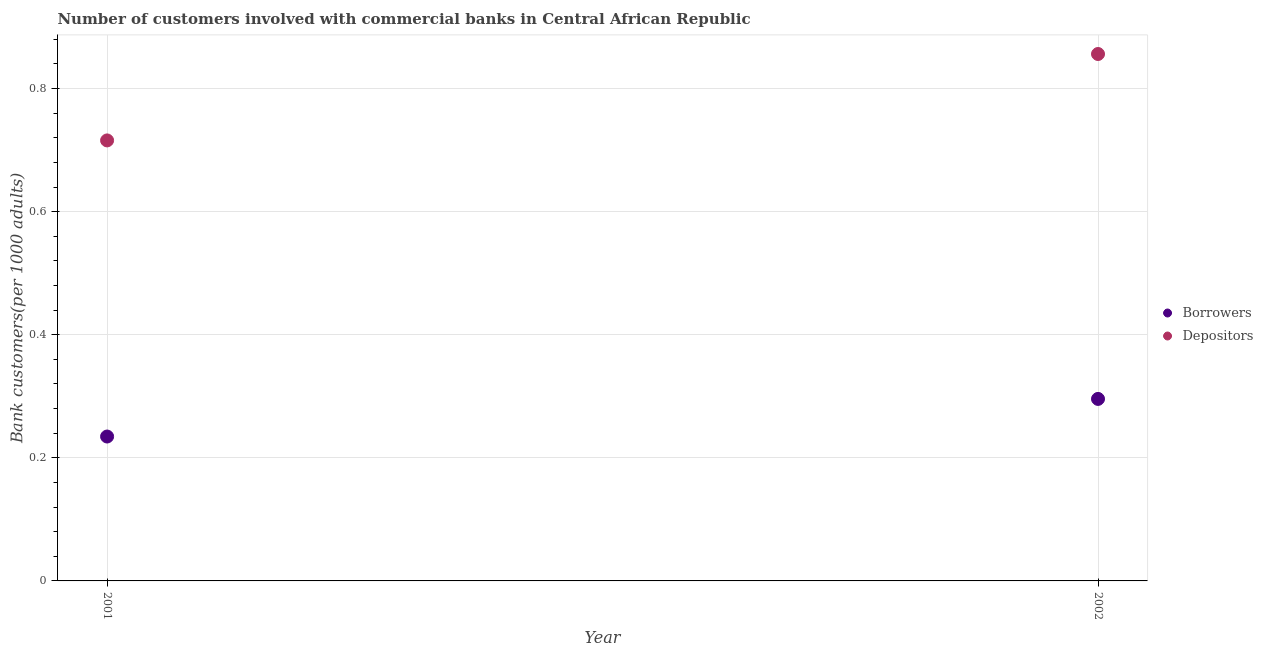Is the number of dotlines equal to the number of legend labels?
Ensure brevity in your answer.  Yes. What is the number of depositors in 2002?
Give a very brief answer. 0.86. Across all years, what is the maximum number of depositors?
Your response must be concise. 0.86. Across all years, what is the minimum number of depositors?
Your answer should be compact. 0.72. In which year was the number of borrowers maximum?
Your answer should be compact. 2002. In which year was the number of depositors minimum?
Your answer should be compact. 2001. What is the total number of borrowers in the graph?
Your response must be concise. 0.53. What is the difference between the number of borrowers in 2001 and that in 2002?
Your answer should be very brief. -0.06. What is the difference between the number of depositors in 2001 and the number of borrowers in 2002?
Provide a succinct answer. 0.42. What is the average number of borrowers per year?
Provide a succinct answer. 0.27. In the year 2001, what is the difference between the number of borrowers and number of depositors?
Make the answer very short. -0.48. What is the ratio of the number of borrowers in 2001 to that in 2002?
Give a very brief answer. 0.79. Is the number of depositors in 2001 less than that in 2002?
Keep it short and to the point. Yes. In how many years, is the number of depositors greater than the average number of depositors taken over all years?
Your response must be concise. 1. Does the number of borrowers monotonically increase over the years?
Offer a very short reply. Yes. Does the graph contain any zero values?
Your answer should be compact. No. Does the graph contain grids?
Offer a very short reply. Yes. What is the title of the graph?
Offer a very short reply. Number of customers involved with commercial banks in Central African Republic. Does "Secondary" appear as one of the legend labels in the graph?
Provide a succinct answer. No. What is the label or title of the X-axis?
Your answer should be very brief. Year. What is the label or title of the Y-axis?
Give a very brief answer. Bank customers(per 1000 adults). What is the Bank customers(per 1000 adults) of Borrowers in 2001?
Make the answer very short. 0.23. What is the Bank customers(per 1000 adults) of Depositors in 2001?
Provide a short and direct response. 0.72. What is the Bank customers(per 1000 adults) of Borrowers in 2002?
Provide a short and direct response. 0.3. What is the Bank customers(per 1000 adults) in Depositors in 2002?
Provide a succinct answer. 0.86. Across all years, what is the maximum Bank customers(per 1000 adults) of Borrowers?
Keep it short and to the point. 0.3. Across all years, what is the maximum Bank customers(per 1000 adults) of Depositors?
Your answer should be very brief. 0.86. Across all years, what is the minimum Bank customers(per 1000 adults) of Borrowers?
Offer a very short reply. 0.23. Across all years, what is the minimum Bank customers(per 1000 adults) of Depositors?
Provide a succinct answer. 0.72. What is the total Bank customers(per 1000 adults) of Borrowers in the graph?
Offer a terse response. 0.53. What is the total Bank customers(per 1000 adults) of Depositors in the graph?
Give a very brief answer. 1.57. What is the difference between the Bank customers(per 1000 adults) in Borrowers in 2001 and that in 2002?
Keep it short and to the point. -0.06. What is the difference between the Bank customers(per 1000 adults) in Depositors in 2001 and that in 2002?
Offer a very short reply. -0.14. What is the difference between the Bank customers(per 1000 adults) of Borrowers in 2001 and the Bank customers(per 1000 adults) of Depositors in 2002?
Your answer should be very brief. -0.62. What is the average Bank customers(per 1000 adults) of Borrowers per year?
Ensure brevity in your answer.  0.27. What is the average Bank customers(per 1000 adults) in Depositors per year?
Your response must be concise. 0.79. In the year 2001, what is the difference between the Bank customers(per 1000 adults) of Borrowers and Bank customers(per 1000 adults) of Depositors?
Your response must be concise. -0.48. In the year 2002, what is the difference between the Bank customers(per 1000 adults) in Borrowers and Bank customers(per 1000 adults) in Depositors?
Give a very brief answer. -0.56. What is the ratio of the Bank customers(per 1000 adults) in Borrowers in 2001 to that in 2002?
Your answer should be very brief. 0.79. What is the ratio of the Bank customers(per 1000 adults) in Depositors in 2001 to that in 2002?
Keep it short and to the point. 0.84. What is the difference between the highest and the second highest Bank customers(per 1000 adults) in Borrowers?
Your response must be concise. 0.06. What is the difference between the highest and the second highest Bank customers(per 1000 adults) in Depositors?
Offer a very short reply. 0.14. What is the difference between the highest and the lowest Bank customers(per 1000 adults) in Borrowers?
Offer a very short reply. 0.06. What is the difference between the highest and the lowest Bank customers(per 1000 adults) of Depositors?
Keep it short and to the point. 0.14. 